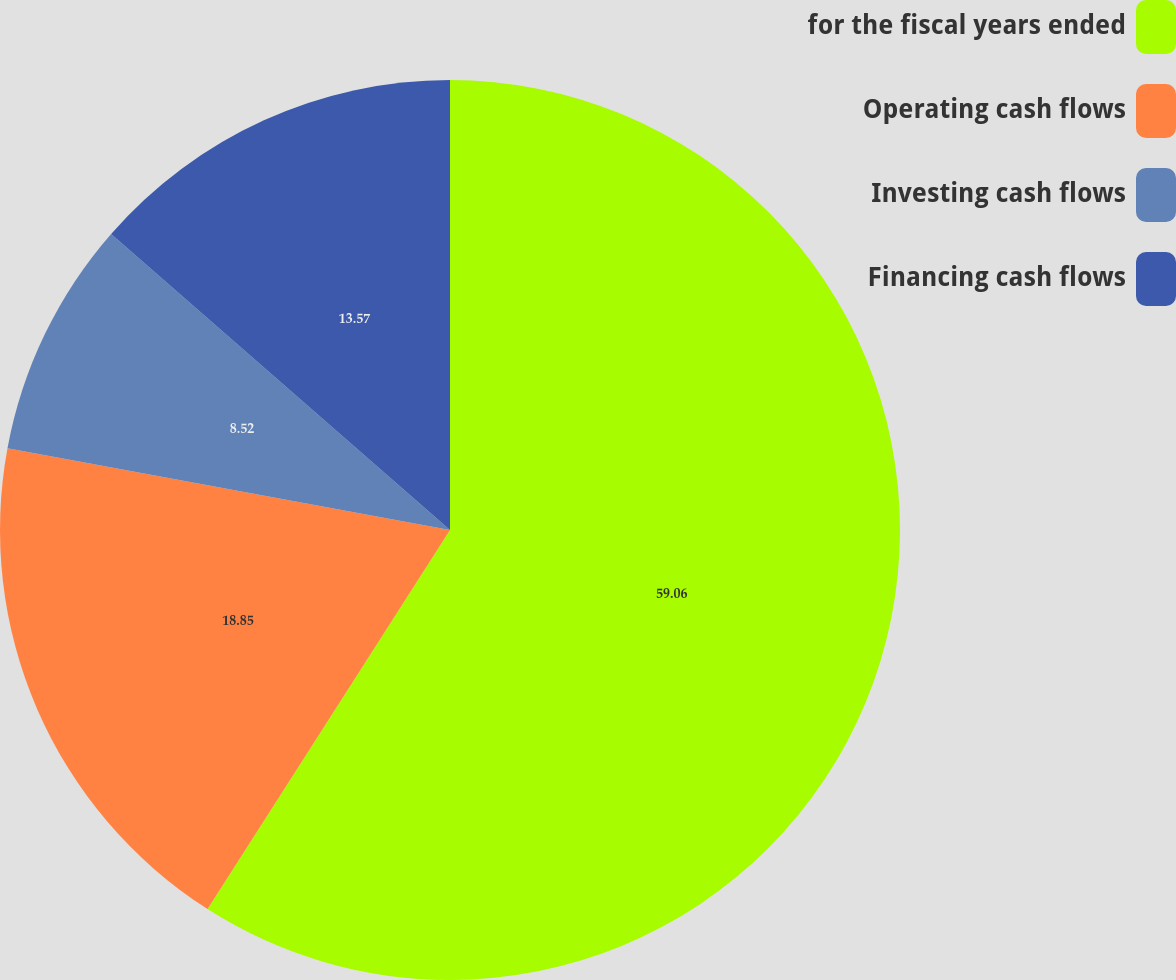<chart> <loc_0><loc_0><loc_500><loc_500><pie_chart><fcel>for the fiscal years ended<fcel>Operating cash flows<fcel>Investing cash flows<fcel>Financing cash flows<nl><fcel>59.05%<fcel>18.85%<fcel>8.52%<fcel>13.57%<nl></chart> 